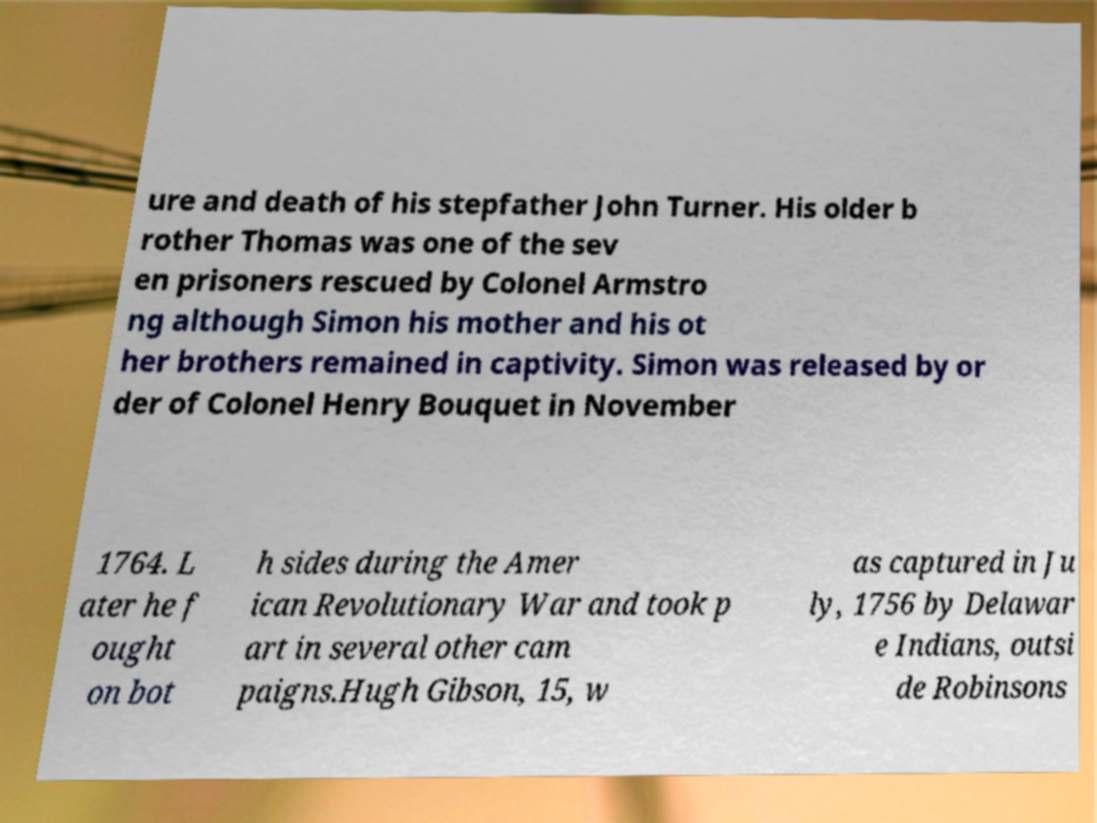What messages or text are displayed in this image? I need them in a readable, typed format. ure and death of his stepfather John Turner. His older b rother Thomas was one of the sev en prisoners rescued by Colonel Armstro ng although Simon his mother and his ot her brothers remained in captivity. Simon was released by or der of Colonel Henry Bouquet in November 1764. L ater he f ought on bot h sides during the Amer ican Revolutionary War and took p art in several other cam paigns.Hugh Gibson, 15, w as captured in Ju ly, 1756 by Delawar e Indians, outsi de Robinsons 